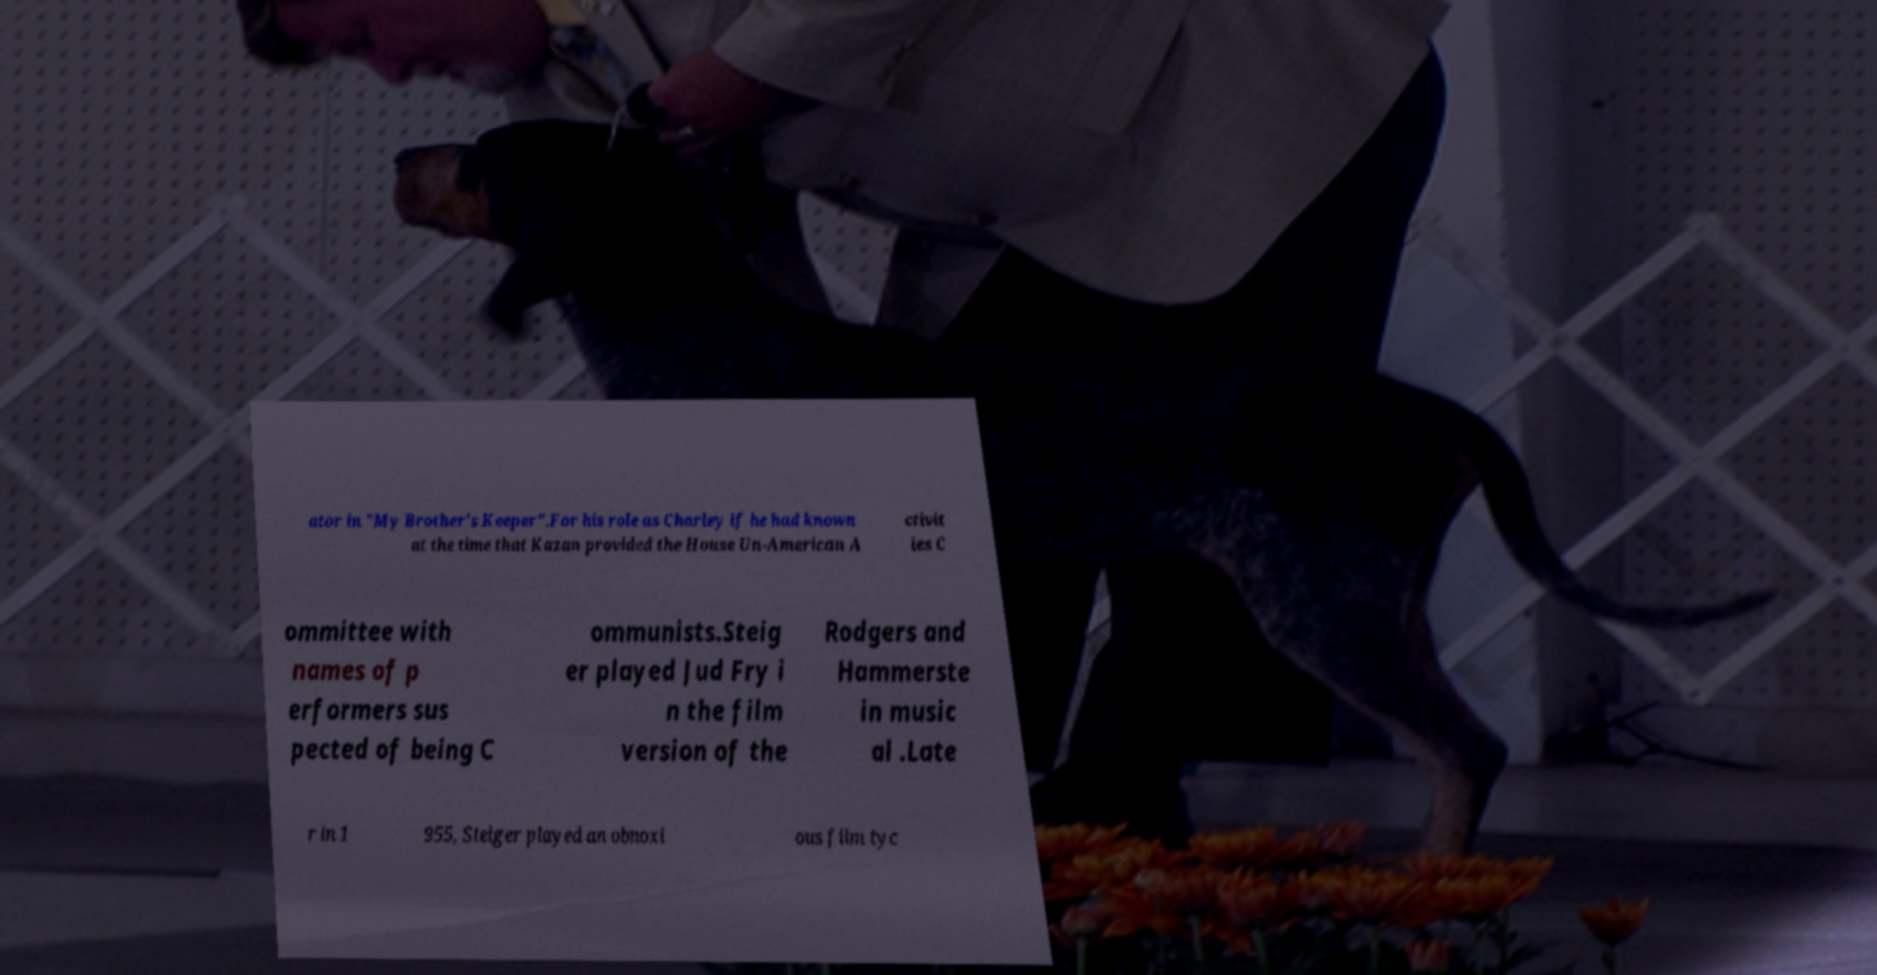I need the written content from this picture converted into text. Can you do that? ator in "My Brother's Keeper".For his role as Charley if he had known at the time that Kazan provided the House Un-American A ctivit ies C ommittee with names of p erformers sus pected of being C ommunists.Steig er played Jud Fry i n the film version of the Rodgers and Hammerste in music al .Late r in 1 955, Steiger played an obnoxi ous film tyc 